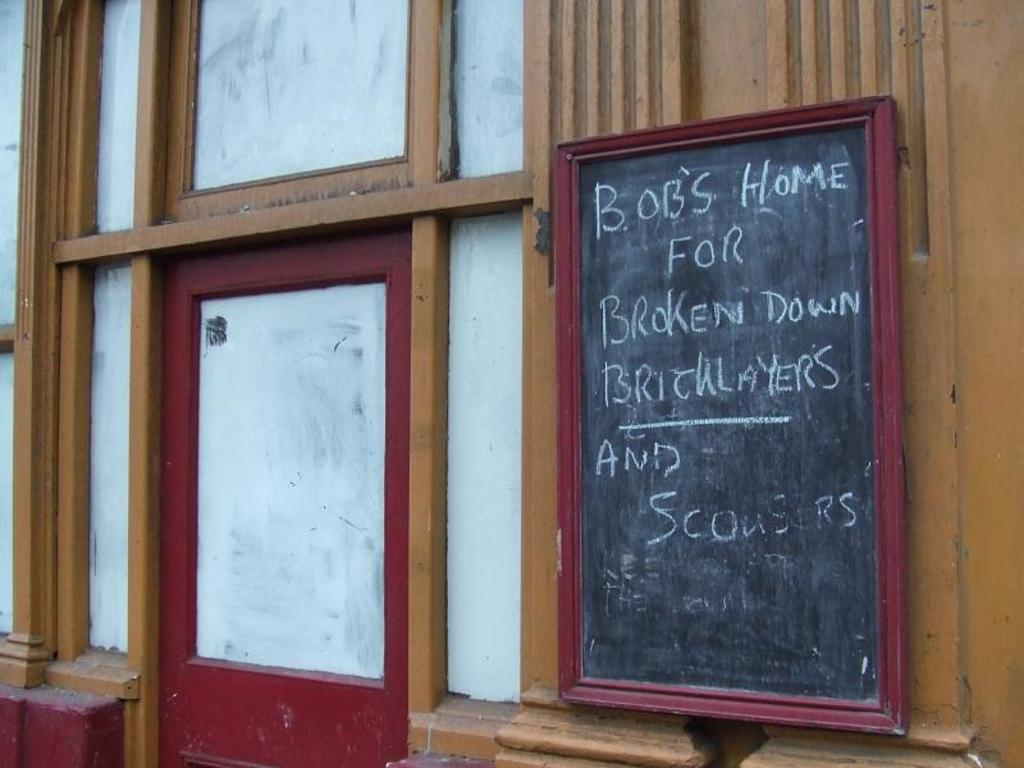What is the main object in the image? There is a blackboard in the image. What is written on the blackboard? Text is written on the blackboard. How is the blackboard attached to the wall? The blackboard is fixed to the wall. What can be seen on the wall around the blackboard? There is a brown, white, and maroon color frame on the wall. What type of oven is visible in the image? There is no oven present in the image; it features a blackboard with text and a frame on the wall. How are the items on the blackboard sorted? The items on the blackboard are not sorted, as the question is based on an assumption that there are items to be sorted, which is not mentioned in the facts. 